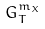Convert formula to latex. <formula><loc_0><loc_0><loc_500><loc_500>G _ { T } ^ { m _ { X } }</formula> 